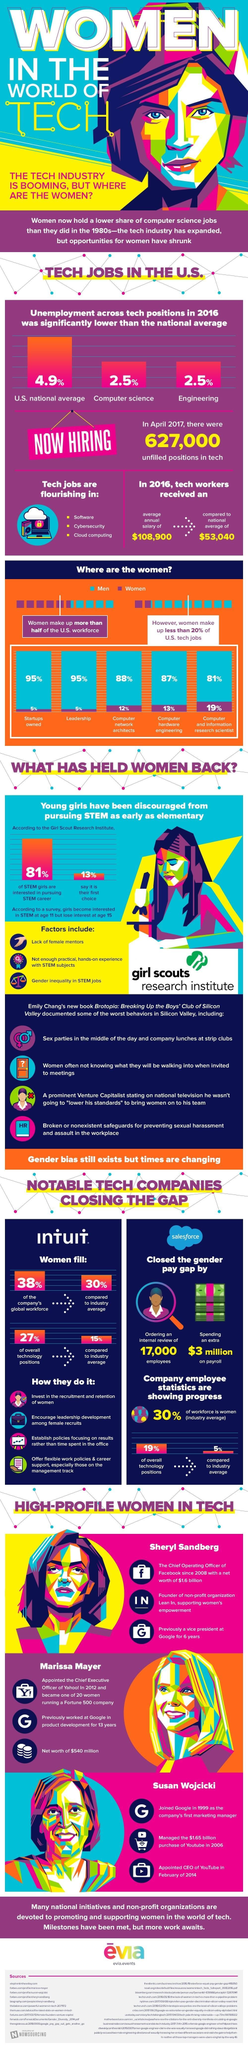What is the job title of 19% of women in the US workforce?
Answer the question with a short phrase. Computer and information research scientist 87% of which gender works in computer hardware engineering? Men Which are the most popular growing technology based jobs? Software, Cybersecurity, Cloud computing 19% of which gender works as Computer and information research scientist? Women What percent of startups are owned by men? 95% What percent of women are computer network architects? 12% 